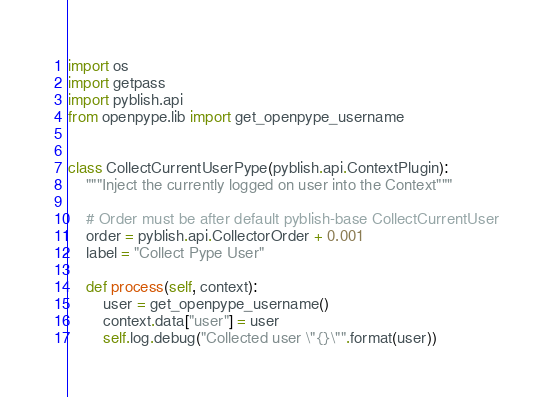<code> <loc_0><loc_0><loc_500><loc_500><_Python_>import os
import getpass
import pyblish.api
from openpype.lib import get_openpype_username


class CollectCurrentUserPype(pyblish.api.ContextPlugin):
    """Inject the currently logged on user into the Context"""

    # Order must be after default pyblish-base CollectCurrentUser
    order = pyblish.api.CollectorOrder + 0.001
    label = "Collect Pype User"

    def process(self, context):
        user = get_openpype_username()
        context.data["user"] = user
        self.log.debug("Collected user \"{}\"".format(user))
</code> 